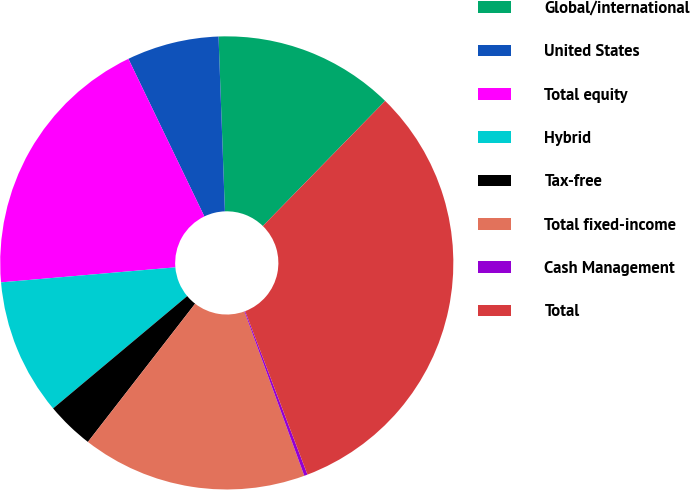Convert chart. <chart><loc_0><loc_0><loc_500><loc_500><pie_chart><fcel>Global/international<fcel>United States<fcel>Total equity<fcel>Hybrid<fcel>Tax-free<fcel>Total fixed-income<fcel>Cash Management<fcel>Total<nl><fcel>12.9%<fcel>6.57%<fcel>19.22%<fcel>9.73%<fcel>3.4%<fcel>16.06%<fcel>0.24%<fcel>31.88%<nl></chart> 